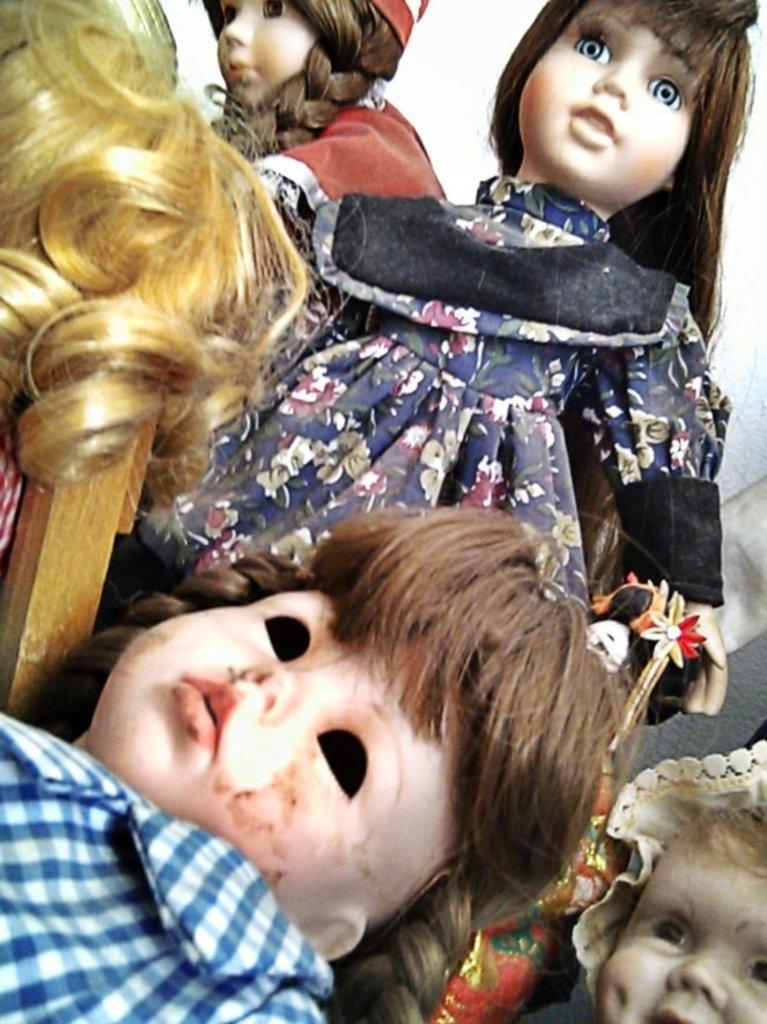How would you summarize this image in a sentence or two? In this image, I can see four dolls with clothes. This looks like a hair. I think this is the wooden stick. 